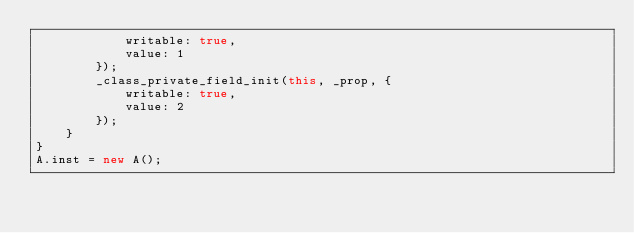<code> <loc_0><loc_0><loc_500><loc_500><_JavaScript_>            writable: true,
            value: 1
        });
        _class_private_field_init(this, _prop, {
            writable: true,
            value: 2
        });
    }
}
A.inst = new A();
</code> 